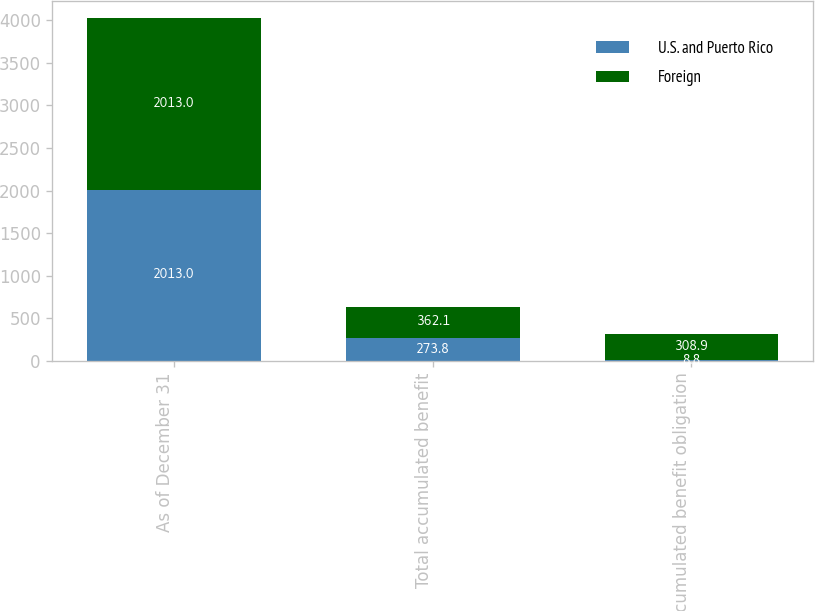Convert chart. <chart><loc_0><loc_0><loc_500><loc_500><stacked_bar_chart><ecel><fcel>As of December 31<fcel>Total accumulated benefit<fcel>Accumulated benefit obligation<nl><fcel>U.S. and Puerto Rico<fcel>2013<fcel>273.8<fcel>8.8<nl><fcel>Foreign<fcel>2013<fcel>362.1<fcel>308.9<nl></chart> 